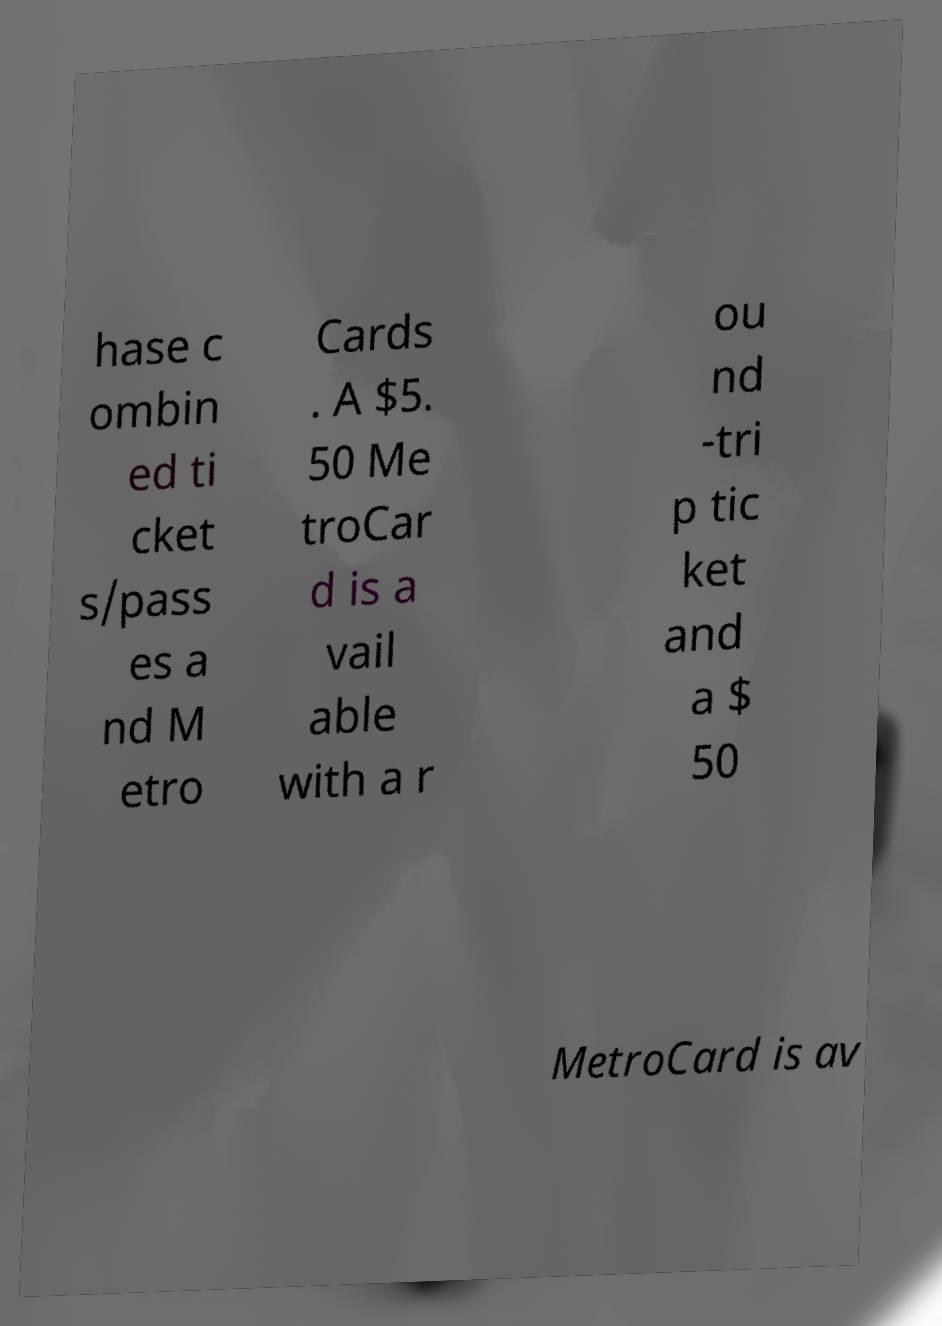Can you read and provide the text displayed in the image?This photo seems to have some interesting text. Can you extract and type it out for me? hase c ombin ed ti cket s/pass es a nd M etro Cards . A $5. 50 Me troCar d is a vail able with a r ou nd -tri p tic ket and a $ 50 MetroCard is av 